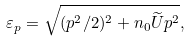Convert formula to latex. <formula><loc_0><loc_0><loc_500><loc_500>\varepsilon _ { p } = \sqrt { ( p ^ { 2 } / 2 ) ^ { 2 } + n _ { 0 } \widetilde { U } p ^ { 2 } } ,</formula> 